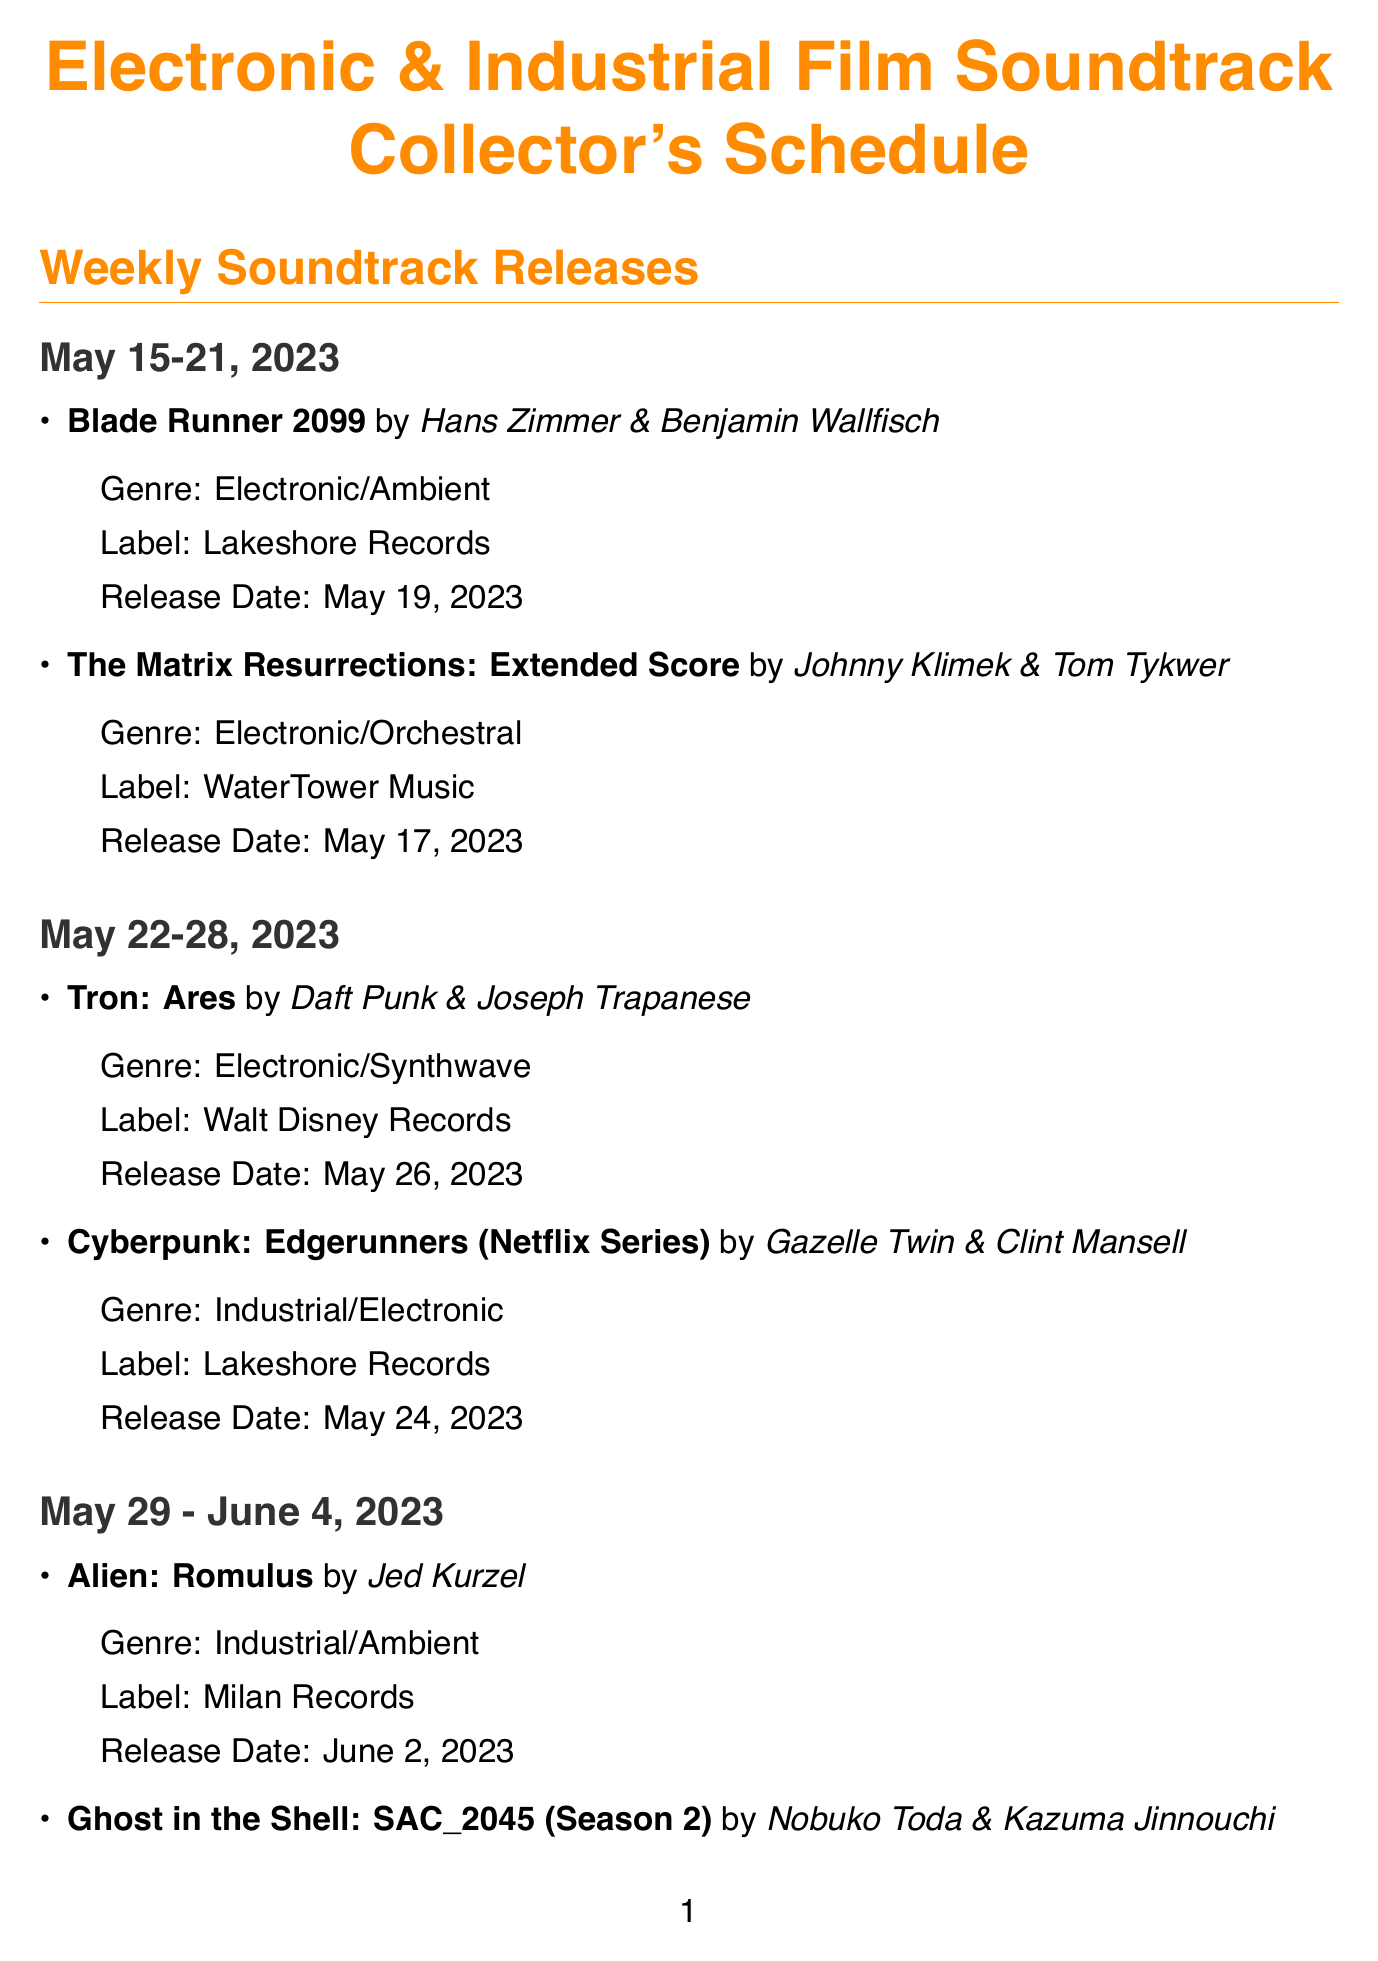What is the release date for Blade Runner 2099? The release date for Blade Runner 2099 is provided under the weekly soundtrack releases section.
Answer: May 19, 2023 Who composed the music for Cyberpunk: Edgerunners? The composer for Cyberpunk: Edgerunners is found in the weekly releases.
Answer: Gazelle Twin & Clint Mansell What genre is the soundtrack for Alien: Romulus? The genre for Alien: Romulus is specified in the weekly soundtrack releases section.
Answer: Industrial/Ambient Which label is releasing The Fifth Element soundtrack? The label for The Fifth Element soundtrack can be found in the vinyl releases section.
Answer: Real Gone Music Who are the featured artists at the Electronic Sound & Screen Festival? The featured artists for the Electronic Sound & Screen Festival are listed in the events section.
Answer: Cliff Martinez, Hildur Guðnadóttir, Ryuichi Sakamoto Which composer is known for The Social Network? The composer associated with The Social Network is listed in the featured composers section.
Answer: Trent Reznor & Atticus Ross How many releases are listed for the week of May 22-28, 2023? The number of releases for the specified week can be counted from the weekly soundtrack releases.
Answer: 2 What is the format of the Akira 30th Anniversary Edition vinyl? The format for the Akira vinyl is detailed in the vinyl releases section.
Answer: 180g Double LP 